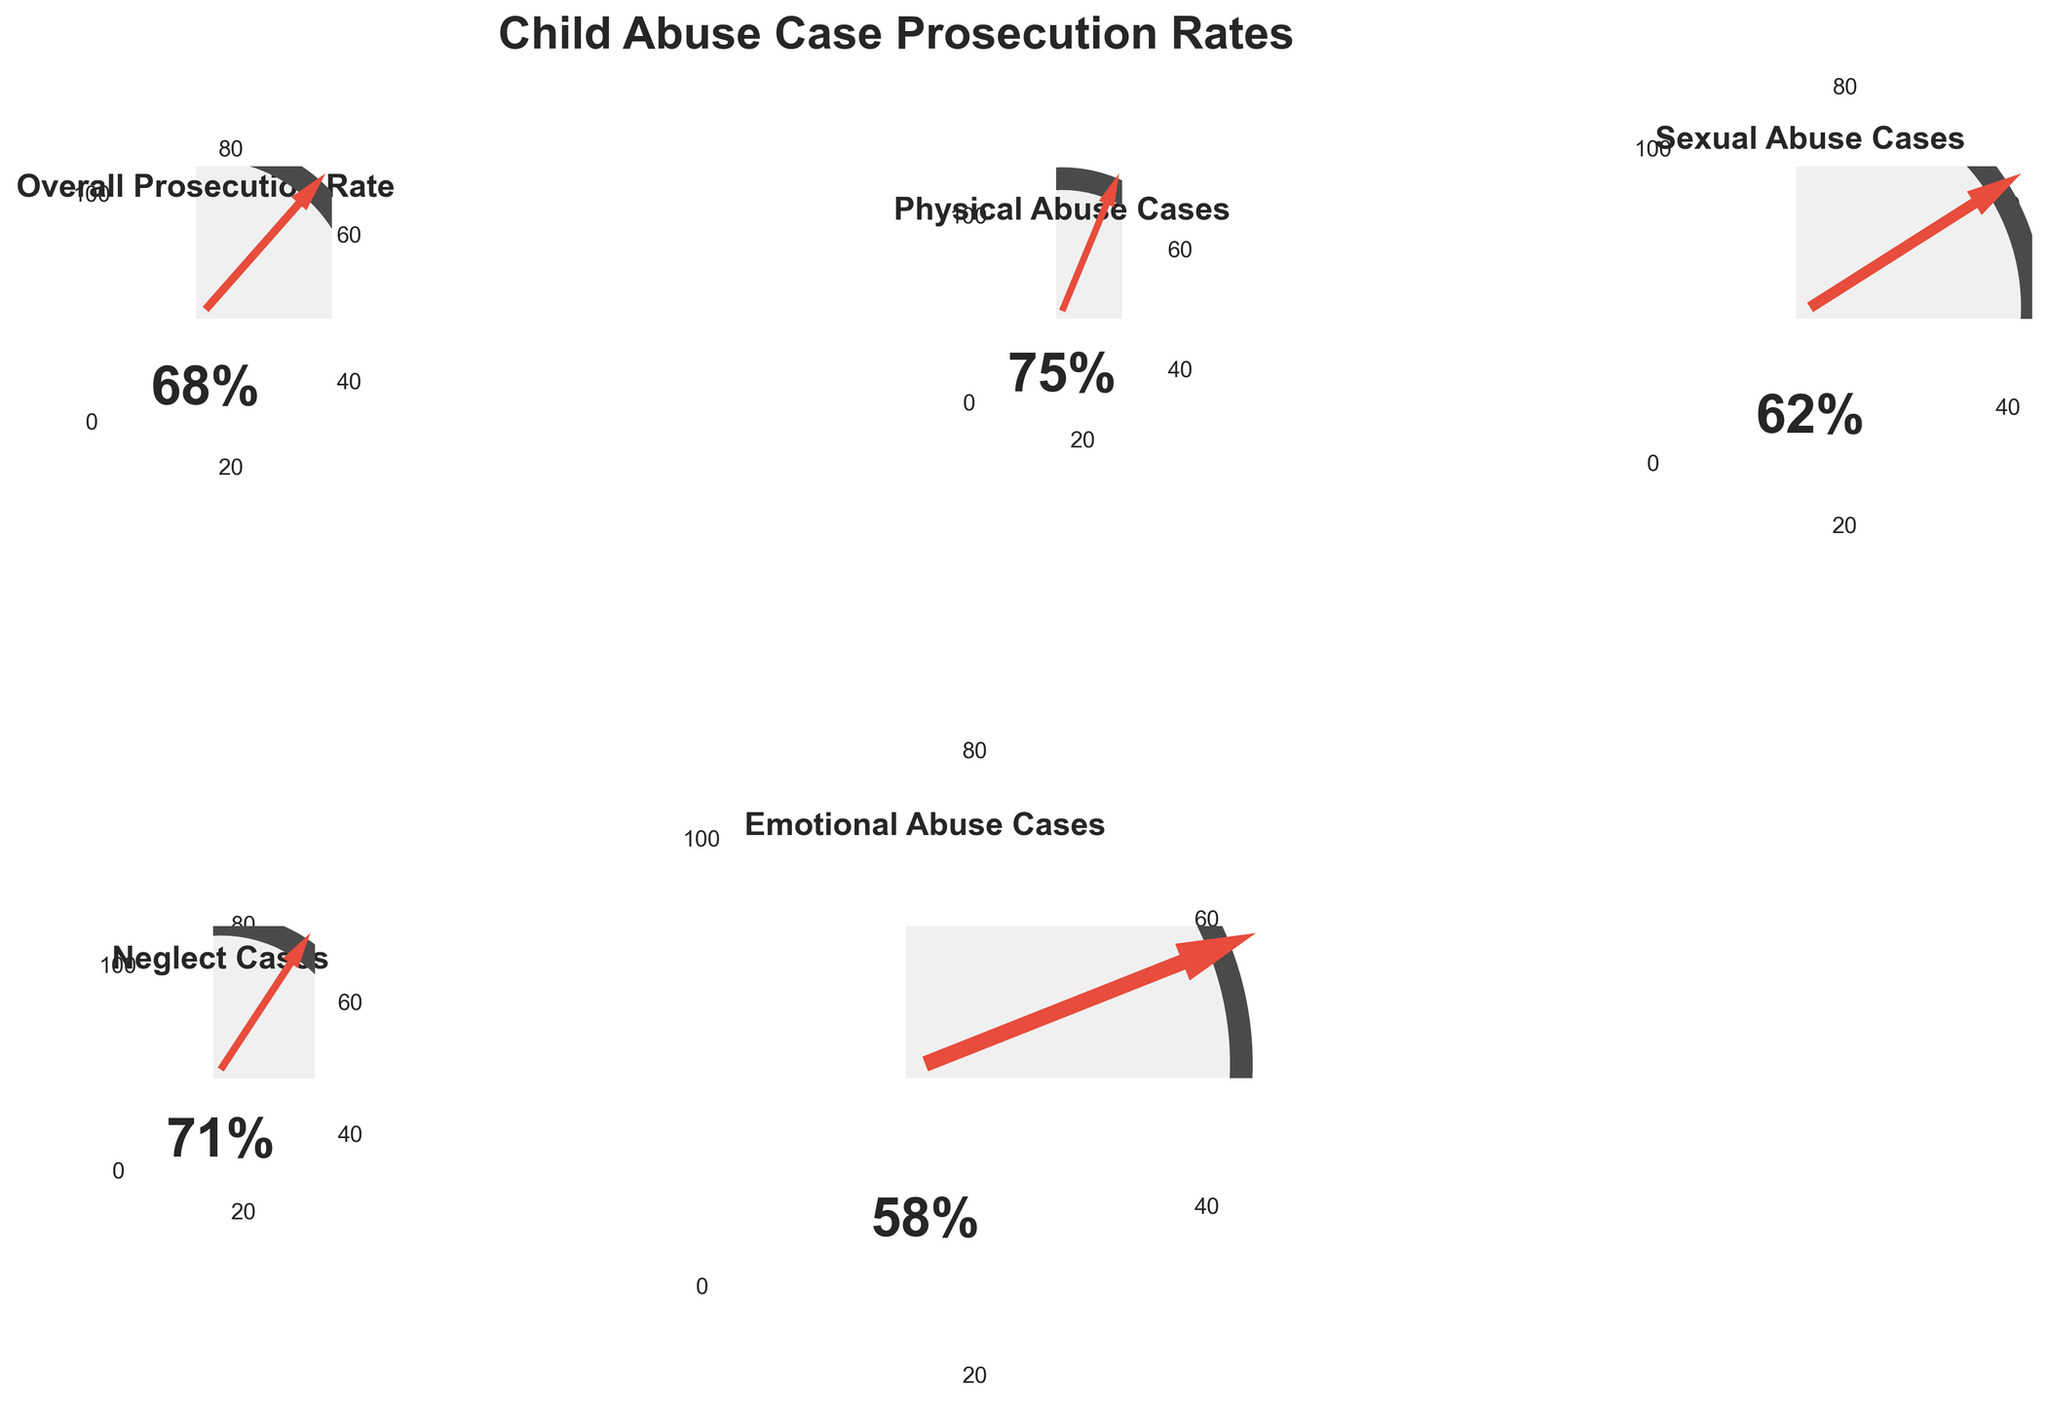What is the title of the figure? The figure's title is usually displayed prominently at the top. In this case, it reads "Child Abuse Case Prosecution Rates."
Answer: Child Abuse Case Prosecution Rates Which type of child abuse case has the lowest prosecution rate? By examining the individual gauge charts, we can identify which has the lowest needle position and percentage. The "Emotional Abuse Cases" has the value of 58%.
Answer: Emotional Abuse Cases What is the prosecution rate for physical abuse cases? The prosecution rate for each type of case is indicated within its respective gauge. For "Physical Abuse Cases," it reads 75% inside the gauge.
Answer: 75% How does the prosecution rate of sexual abuse cases compare to neglect cases? To compare, observe the needle positions or numeric values of both gauges. Sexual abuse cases have a prosecution rate of 62%, while neglect cases have 71%.
Answer: Sexual abuse cases have a lower prosecution rate than neglect cases What is the difference in prosecution rates between the highest and lowest categories? Identify the highest and lowest prosecution rates from the gauges: Physical Abuse (75%) and Emotional Abuse (58%). Calculate the difference: 75 - 58 = 17.
Answer: 17% What is the average prosecution rate across all categories? Calculate the average by adding all the prosecution rates and dividing by the number of categories. (68 + 75 + 62 + 71 + 58) / 5 = 66.8%.
Answer: 66.8% Which category is closest to the overall prosecution rate? The overall prosecution rate is 68%. By comparing each category's rate: Physical Abuse (75%), Sexual Abuse (62%), Neglect (71%), Emotional Abuse (58%), the closest one is Neglect Cases at 71%.
Answer: Neglect Cases How many child abuse categories had a prosecution rate higher than the overall prosecution rate? Compare each category's rate to the overall rate (68%). Physical Abuse (75%) and Neglect (71%) are both higher.
Answer: 2 categories Are there any categories with prosecution rates above 70%? Examine each gauge for rates above 70%. Physical Abuse (75%) and Neglect (71%) both meet this criterion.
Answer: Yes, two categories What would be the median prosecution rate of these categories? Order the rates: 58, 62, 68, 71, 75. The median value, which is the middle one when ordered, is 68%.
Answer: 68% 